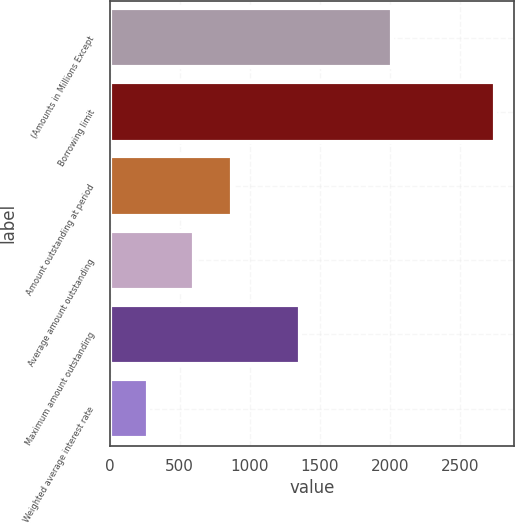Convert chart. <chart><loc_0><loc_0><loc_500><loc_500><bar_chart><fcel>(Amounts in Millions Except<fcel>Borrowing limit<fcel>Amount outstanding at period<fcel>Average amount outstanding<fcel>Maximum amount outstanding<fcel>Weighted average interest rate<nl><fcel>2015<fcel>2750<fcel>875.95<fcel>601<fcel>1360<fcel>275.43<nl></chart> 